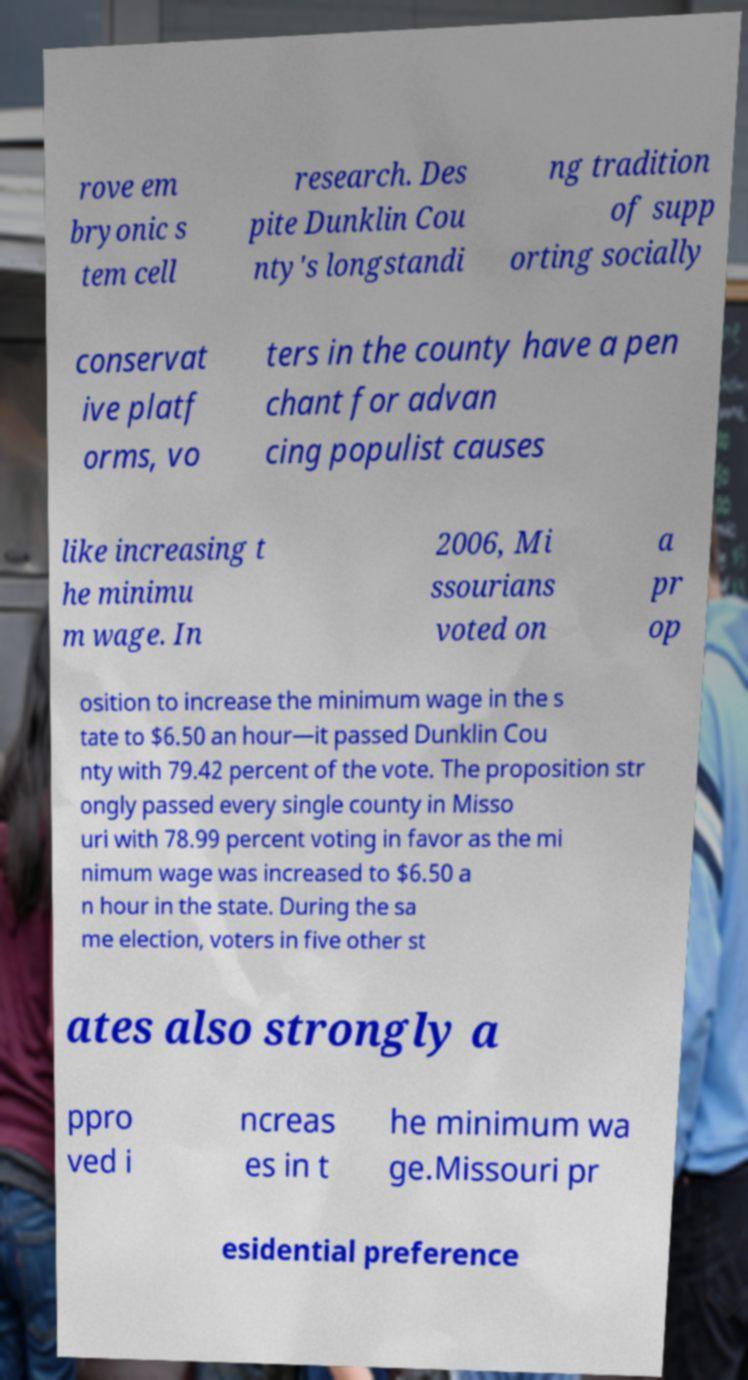Please read and relay the text visible in this image. What does it say? rove em bryonic s tem cell research. Des pite Dunklin Cou nty's longstandi ng tradition of supp orting socially conservat ive platf orms, vo ters in the county have a pen chant for advan cing populist causes like increasing t he minimu m wage. In 2006, Mi ssourians voted on a pr op osition to increase the minimum wage in the s tate to $6.50 an hour—it passed Dunklin Cou nty with 79.42 percent of the vote. The proposition str ongly passed every single county in Misso uri with 78.99 percent voting in favor as the mi nimum wage was increased to $6.50 a n hour in the state. During the sa me election, voters in five other st ates also strongly a ppro ved i ncreas es in t he minimum wa ge.Missouri pr esidential preference 